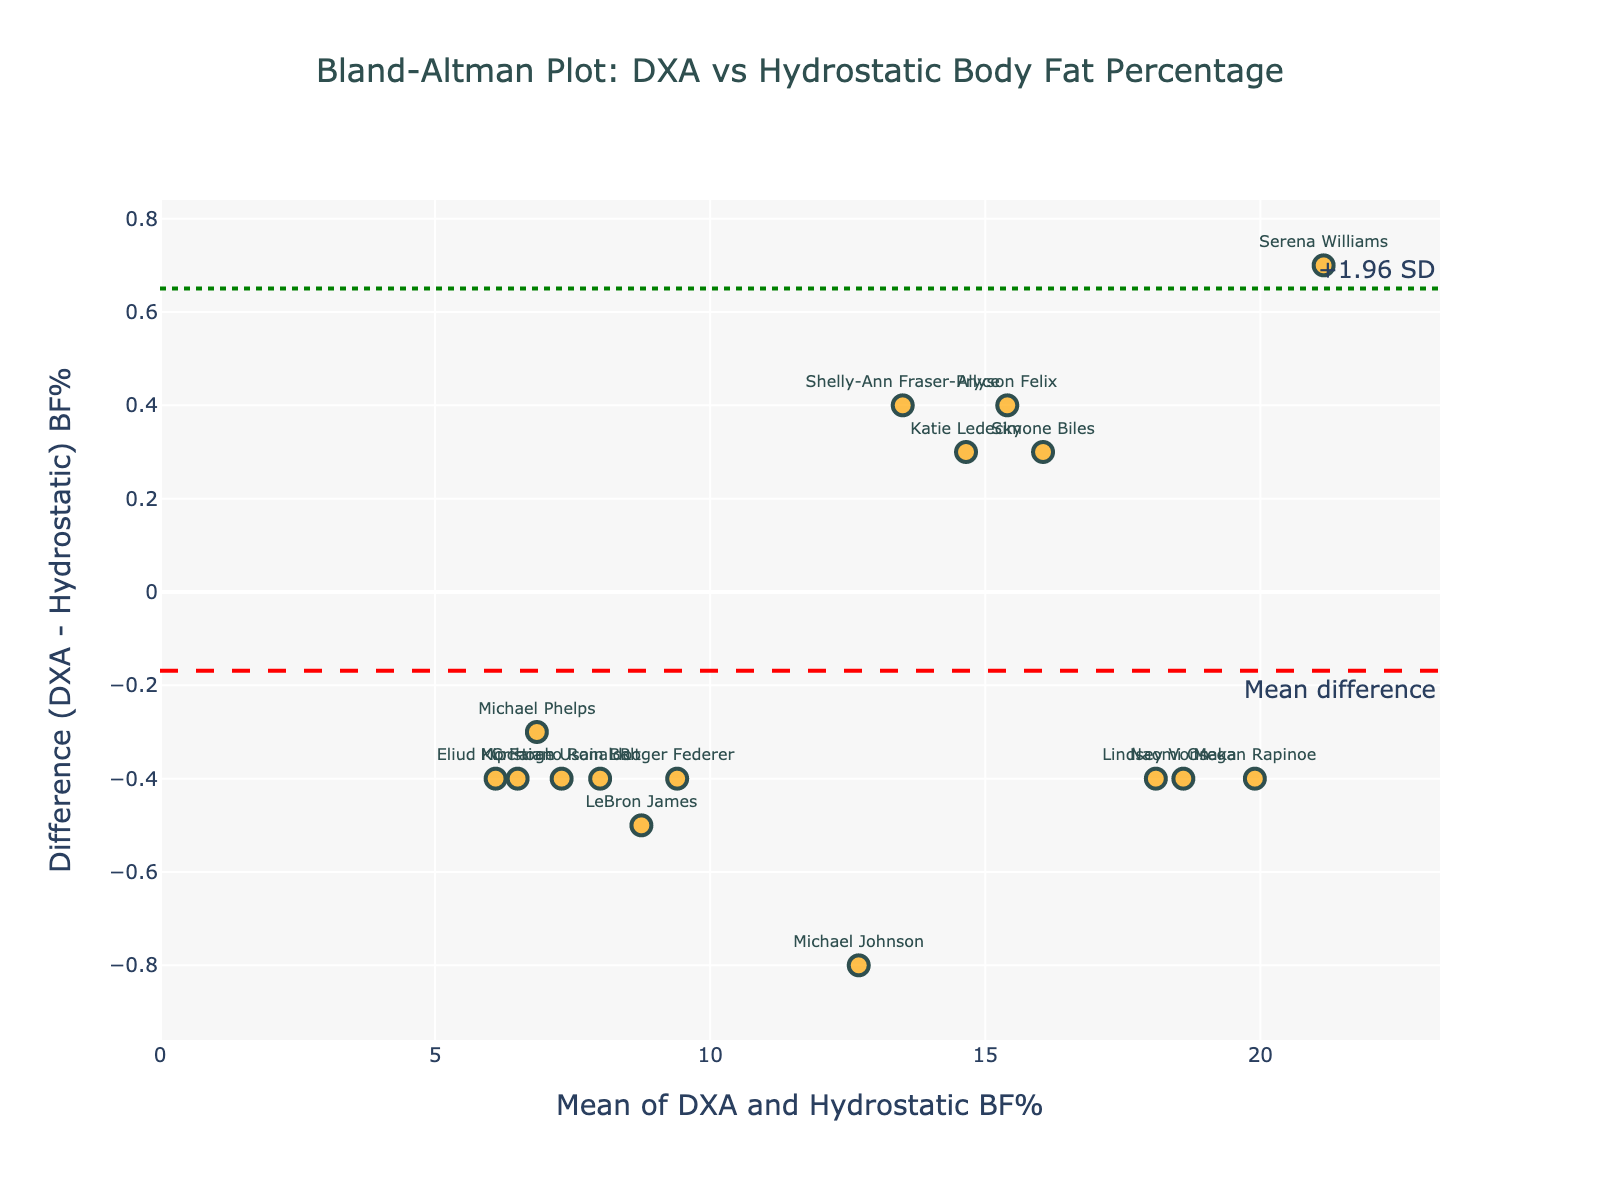How many athletes are represented in the Bland-Altman plot? By counting the number of data points (markers) on the plot, we can determine how many athletes are represented. Each marker corresponds to one athlete.
Answer: 16 What does the red dashed line represent in the plot? The red dashed line represents the mean difference between the two measurement methods. This is visually shown on the plot and is an essential feature of Bland-Altman plots.
Answer: Mean difference Which athlete has the highest average body fat percentage between the two measurement methods? By looking at the x-axis, which shows the mean body fat percentage, we identify the athlete represented by the point farthest to the right.
Answer: Serena Williams What are the values of the upper and lower limits of agreement? The upper and lower limits of agreement are shown by the green dotted lines. The upper limit of agreement is the mean difference plus 1.96 times the standard deviation of the differences, and the lower limit includes minus 1.96 times the standard deviation. These values are visually represented with annotations on the plot.
Answer: Upper: +1.96 SD, Lower: -1.96 SD What is the range of differences in body fat percentage between DXA and hydrostatic methods? The y-axis represents the difference in body fat percentages between the two methods. The range can be observed from the minimum to maximum values on this axis.
Answer: Approximately -1 to +1.5 Which athlete shows the largest discrepancy between DXA and hydrostatic body fat percentages? The athlete showing the largest discrepancy will have the marker farthest from the red dashed line (mean difference line) on the y-axis. We look for the point with the maximum or minimum difference value.
Answer: Michael Johnson What does the green dotted line above the red dashed line indicate? The green dotted line above the red dashed line represents the upper limit of agreement, which is the mean difference plus 1.96 times the standard deviation of the differences.
Answer: +1.96 SD Is there a pattern visible in the differences as related to the average body fat percentage? To identify a pattern, we observe if the differences (y-axis) change consistently with the average values (x-axis). Patterns might indicate a systematic bias or trend.
Answer: No obvious pattern What could be inferred if most points lie within the range of the green dotted lines? If most points lie within the limits set by the green dotted lines, it indicates that the agreement between the two measurement methods is acceptable as most differences fall within the expected range of variability.
Answer: Good agreement Are there any athletes with a negative difference between the two body fat measurement methods? Negative differences indicate that the value measured by DXA is less than the value measured by the hydrostatic method. These points lie below the red dashed line.
Answer: Yes Which athletic activities correspond to athletes with the lowest average body fat percentages? By identifying the names of athletes at the lower end of the x-axis and knowing their respective sports, we can determine which activities correspond to lower body fat percentages.
Answer: Distance running (e.g., Eliud Kipchoge, Mo Farah) 